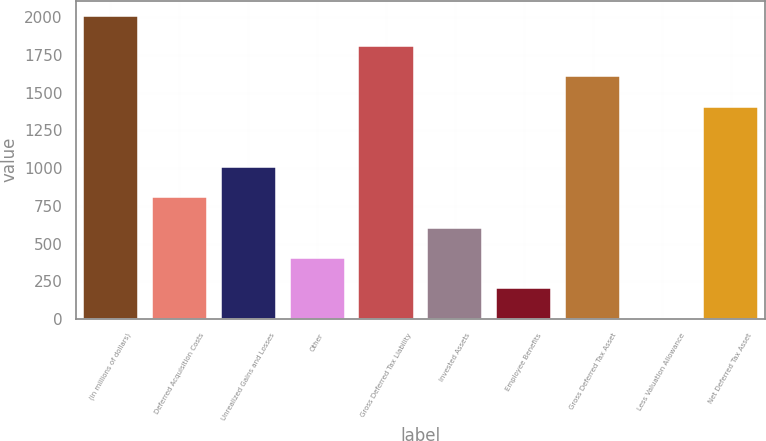Convert chart. <chart><loc_0><loc_0><loc_500><loc_500><bar_chart><fcel>(in millions of dollars)<fcel>Deferred Acquisition Costs<fcel>Unrealized Gains and Losses<fcel>Other<fcel>Gross Deferred Tax Liability<fcel>Invested Assets<fcel>Employee Benefits<fcel>Gross Deferred Tax Asset<fcel>Less Valuation Allowance<fcel>Net Deferred Tax Asset<nl><fcel>2010<fcel>806.46<fcel>1007.05<fcel>405.28<fcel>1809.41<fcel>605.87<fcel>204.69<fcel>1608.82<fcel>4.1<fcel>1408.23<nl></chart> 